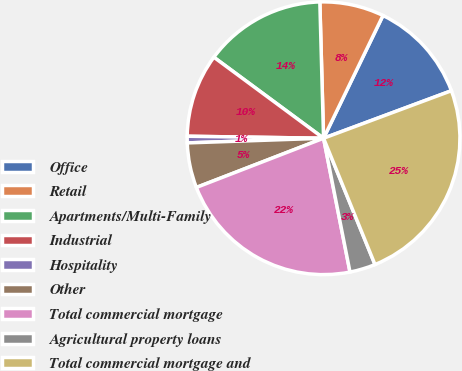<chart> <loc_0><loc_0><loc_500><loc_500><pie_chart><fcel>Office<fcel>Retail<fcel>Apartments/Multi-Family<fcel>Industrial<fcel>Hospitality<fcel>Other<fcel>Total commercial mortgage<fcel>Agricultural property loans<fcel>Total commercial mortgage and<nl><fcel>12.16%<fcel>7.61%<fcel>14.44%<fcel>9.89%<fcel>0.78%<fcel>5.33%<fcel>22.23%<fcel>3.05%<fcel>24.51%<nl></chart> 